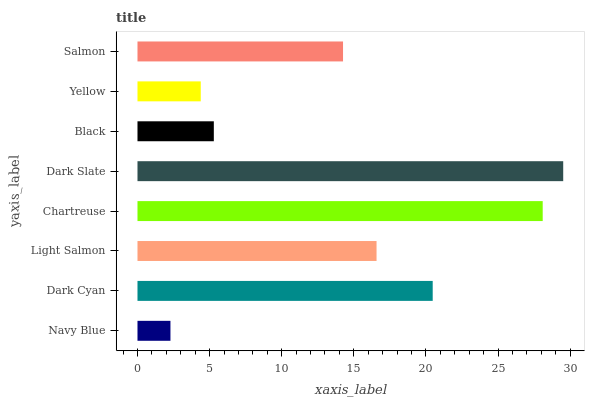Is Navy Blue the minimum?
Answer yes or no. Yes. Is Dark Slate the maximum?
Answer yes or no. Yes. Is Dark Cyan the minimum?
Answer yes or no. No. Is Dark Cyan the maximum?
Answer yes or no. No. Is Dark Cyan greater than Navy Blue?
Answer yes or no. Yes. Is Navy Blue less than Dark Cyan?
Answer yes or no. Yes. Is Navy Blue greater than Dark Cyan?
Answer yes or no. No. Is Dark Cyan less than Navy Blue?
Answer yes or no. No. Is Light Salmon the high median?
Answer yes or no. Yes. Is Salmon the low median?
Answer yes or no. Yes. Is Navy Blue the high median?
Answer yes or no. No. Is Black the low median?
Answer yes or no. No. 